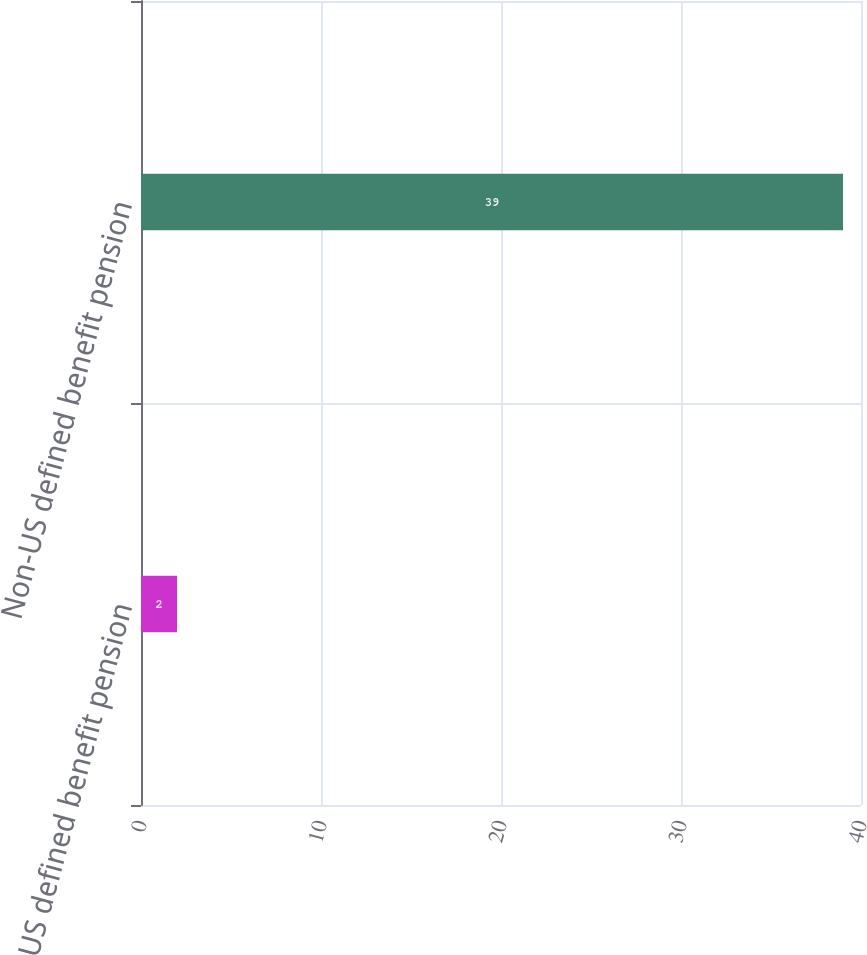Convert chart to OTSL. <chart><loc_0><loc_0><loc_500><loc_500><bar_chart><fcel>US defined benefit pension<fcel>Non-US defined benefit pension<nl><fcel>2<fcel>39<nl></chart> 